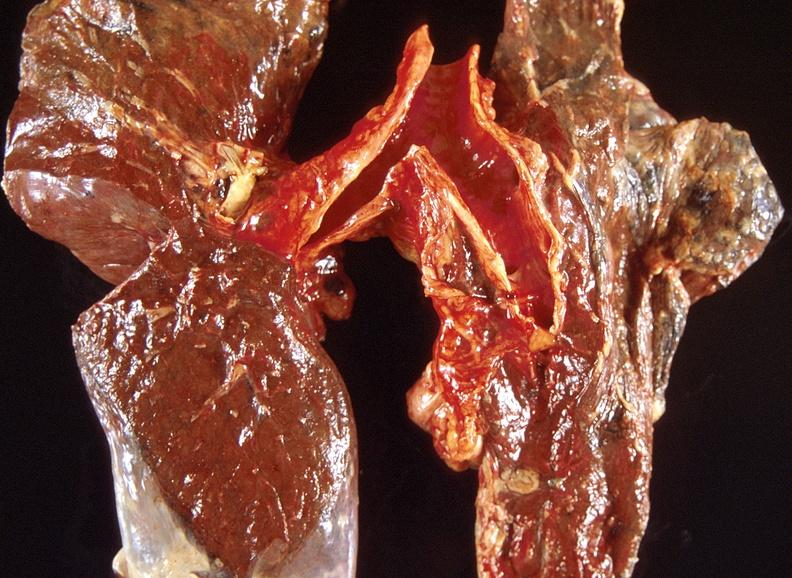does this image show lung carcinoma?
Answer the question using a single word or phrase. Yes 